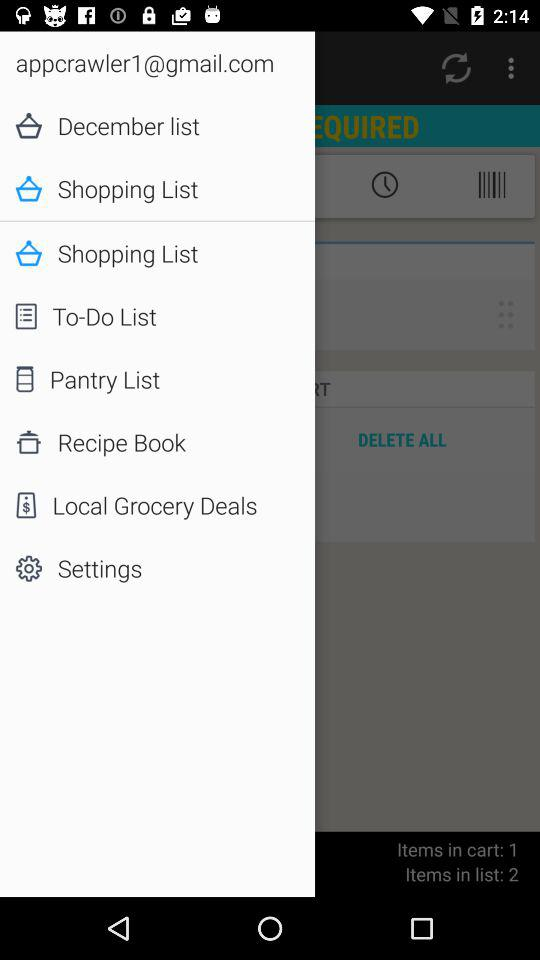What is the count of items in the cart? The count of items in the cart is 1. 